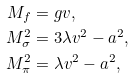<formula> <loc_0><loc_0><loc_500><loc_500>M _ { f } & = g v , \\ M _ { \sigma } ^ { 2 } & = 3 \lambda v ^ { 2 } - a ^ { 2 } , \\ M _ { \pi } ^ { 2 } & = \lambda v ^ { 2 } - a ^ { 2 } ,</formula> 